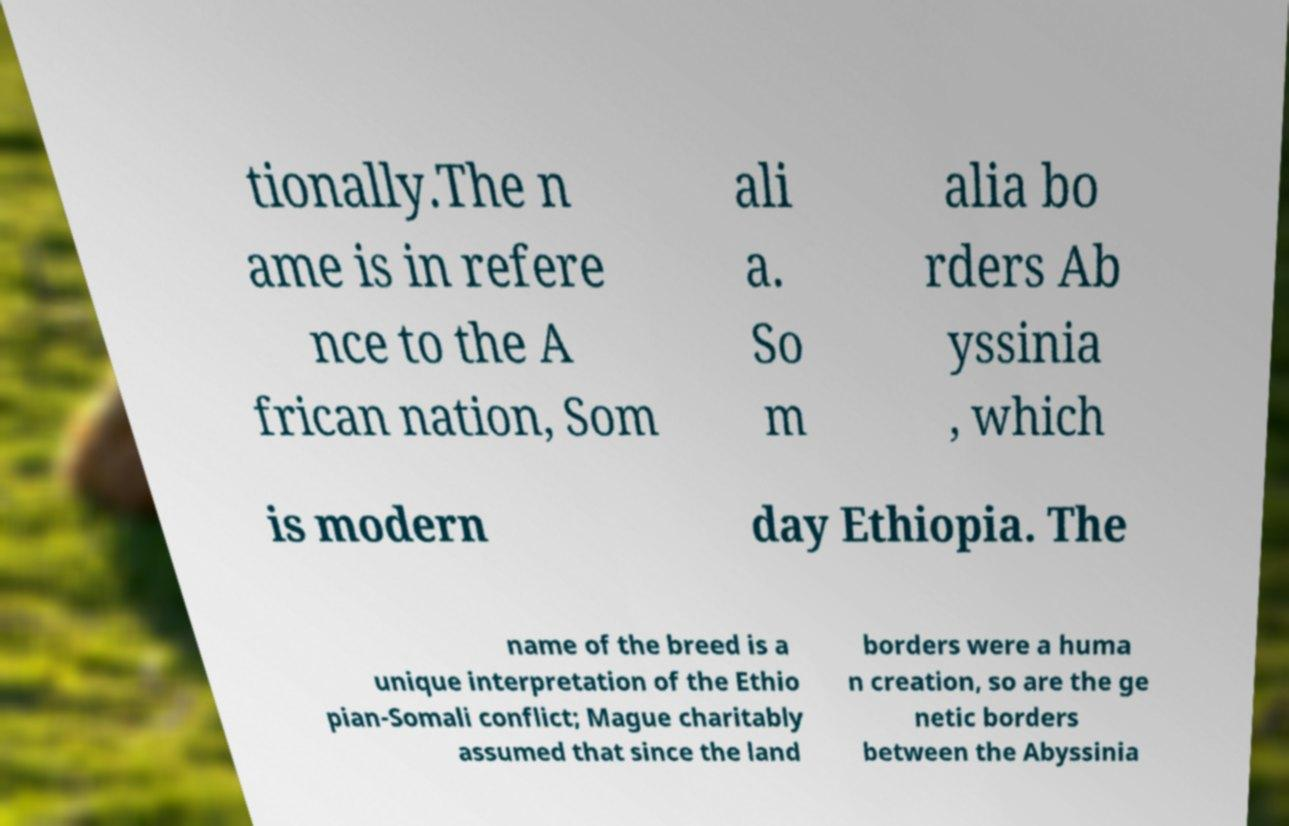Could you assist in decoding the text presented in this image and type it out clearly? tionally.The n ame is in refere nce to the A frican nation, Som ali a. So m alia bo rders Ab yssinia , which is modern day Ethiopia. The name of the breed is a unique interpretation of the Ethio pian-Somali conflict; Mague charitably assumed that since the land borders were a huma n creation, so are the ge netic borders between the Abyssinia 